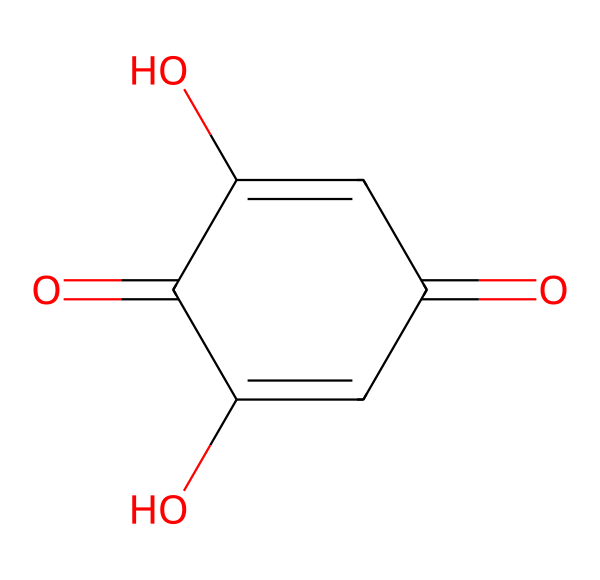how many carbon atoms are in this structure? The SMILES representation shows the chemical structure, and by examining it, we can count the distinct carbon atoms in the cyclic arrangement. There are six carbon atoms present in this structure.
Answer: six what type of functional groups are present? The structure contains carbonyl (C=O) and hydroxyl (–OH) functional groups. Examining the cyclic structure, we can identify the two carbonyl groups at the 1 and 3 positions and hydroxyl groups on the 2 and 5 positions.
Answer: carbonyl and hydroxyl what is the molecular formula associated with this chemical? From analyzing the SMILES notation, we can deduce that it contains 6 carbon atoms, 6 hydrogen atoms, and 4 oxygen atoms. Therefore, the molecular formula is C6H6O4.
Answer: C6H6O4 is this dye natural or synthetic? The henna dye derived from the plant Lawsonia inermis predominantly contains the molecule depicted. This poses that it is a natural dye.
Answer: natural what property allows this dye to impart color? The conjugated double bonds within the structure enhance light absorption, leading to the vibrant color characteristic of henna. The relevance of the specific arrangement of double bonds plays a pivotal role in its chromophoric characteristics.
Answer: conjugated double bonds how does the presence of hydroxyl groups affect the dye? The hydroxyl groups in the chemical structure allow for hydrogen bonding with hair and skin, thus improving the adherence of the dye, which enhances its ability to impart color effectively.
Answer: improves adherence 